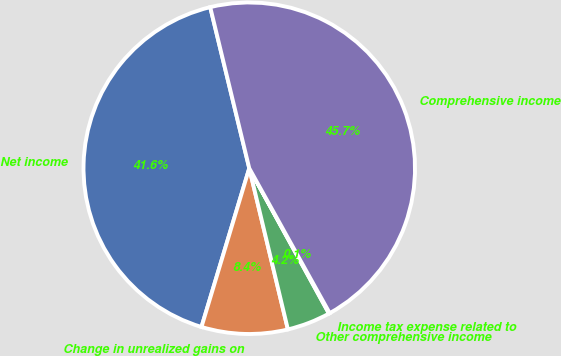Convert chart. <chart><loc_0><loc_0><loc_500><loc_500><pie_chart><fcel>Net income<fcel>Change in unrealized gains on<fcel>Other comprehensive income<fcel>Income tax expense related to<fcel>Comprehensive income<nl><fcel>41.56%<fcel>8.4%<fcel>4.24%<fcel>0.08%<fcel>45.72%<nl></chart> 